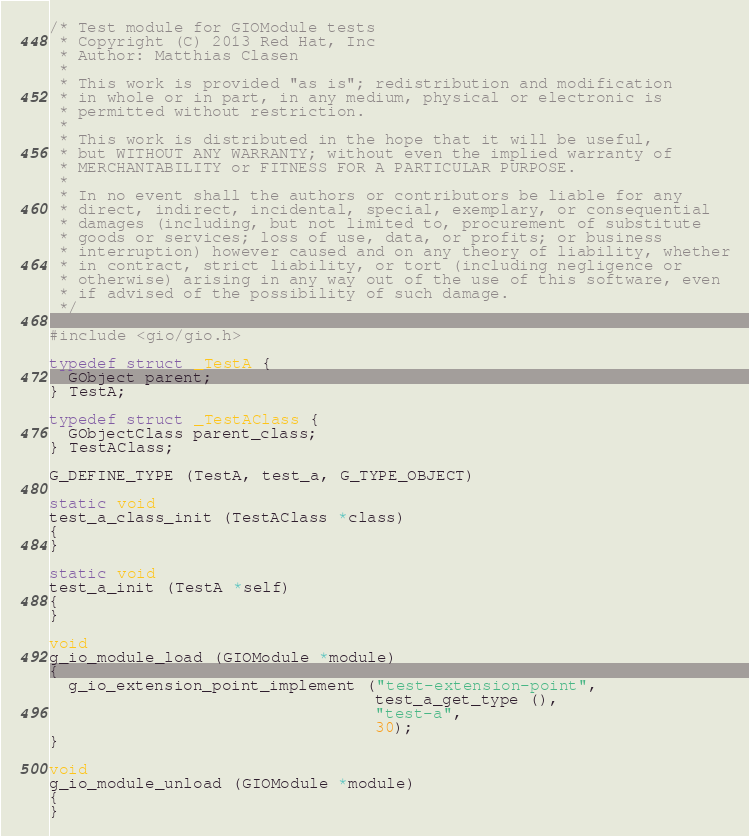<code> <loc_0><loc_0><loc_500><loc_500><_C_>/* Test module for GIOModule tests
 * Copyright (C) 2013 Red Hat, Inc
 * Author: Matthias Clasen
 *
 * This work is provided "as is"; redistribution and modification
 * in whole or in part, in any medium, physical or electronic is
 * permitted without restriction.
 *
 * This work is distributed in the hope that it will be useful,
 * but WITHOUT ANY WARRANTY; without even the implied warranty of
 * MERCHANTABILITY or FITNESS FOR A PARTICULAR PURPOSE.
 *
 * In no event shall the authors or contributors be liable for any
 * direct, indirect, incidental, special, exemplary, or consequential
 * damages (including, but not limited to, procurement of substitute
 * goods or services; loss of use, data, or profits; or business
 * interruption) however caused and on any theory of liability, whether
 * in contract, strict liability, or tort (including negligence or
 * otherwise) arising in any way out of the use of this software, even
 * if advised of the possibility of such damage.
 */

#include <gio/gio.h>

typedef struct _TestA {
  GObject parent;
} TestA;

typedef struct _TestAClass {
  GObjectClass parent_class;
} TestAClass;

G_DEFINE_TYPE (TestA, test_a, G_TYPE_OBJECT)

static void
test_a_class_init (TestAClass *class)
{
}

static void
test_a_init (TestA *self)
{
}

void
g_io_module_load (GIOModule *module)
{
  g_io_extension_point_implement ("test-extension-point",
                                  test_a_get_type (),
                                  "test-a",
                                  30);
}

void
g_io_module_unload (GIOModule *module)
{
}
</code> 